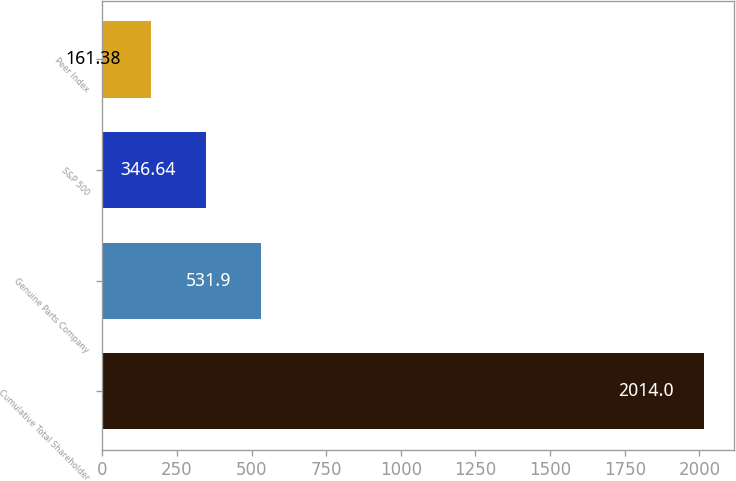Convert chart. <chart><loc_0><loc_0><loc_500><loc_500><bar_chart><fcel>Cumulative Total Shareholder<fcel>Genuine Parts Company<fcel>S&P 500<fcel>Peer Index<nl><fcel>2014<fcel>531.9<fcel>346.64<fcel>161.38<nl></chart> 